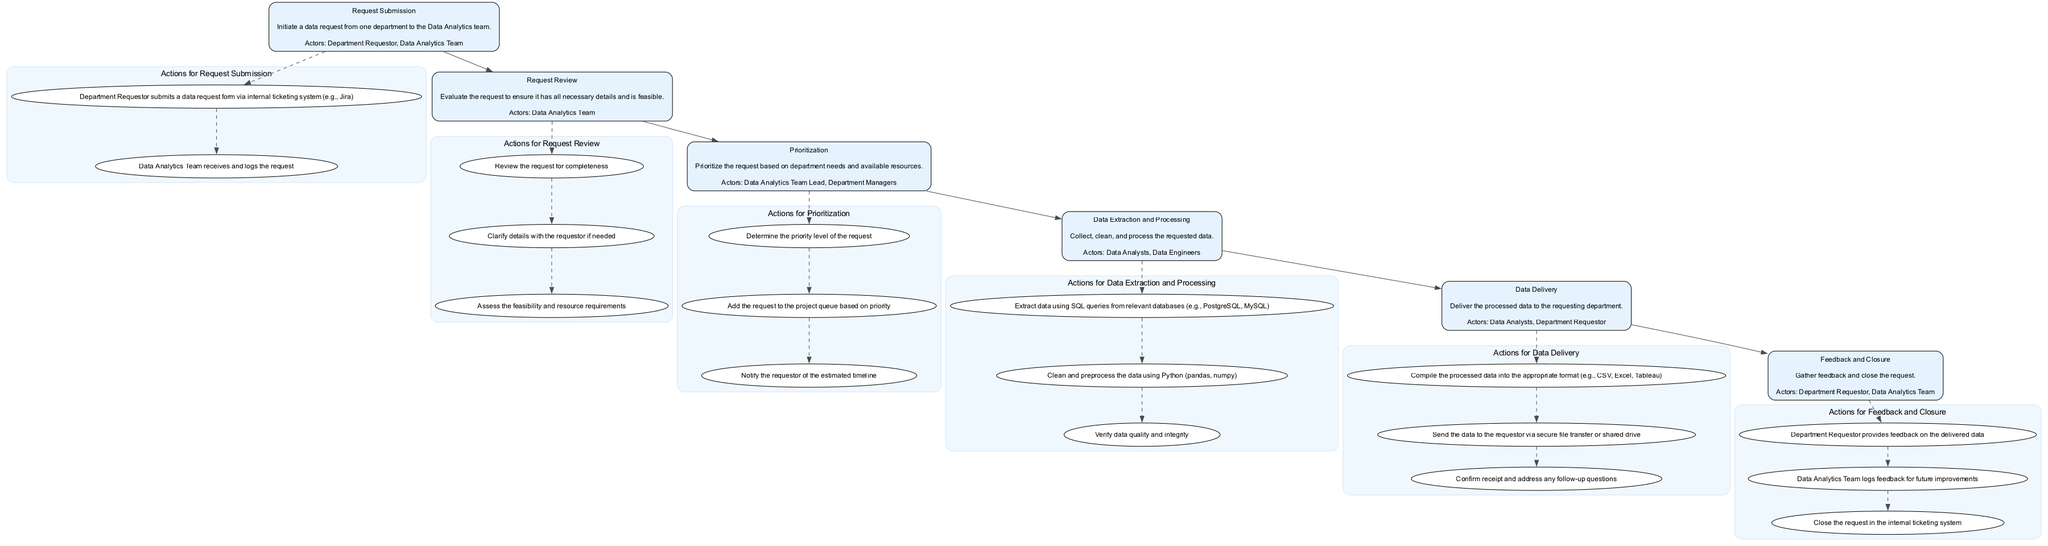What is the first stage in the process? The process begins with the "Request Submission" stage, which is the first node listed in the diagram.
Answer: Request Submission How many actors are involved in the "Data Extraction and Processing" stage? The "Data Extraction and Processing" stage has two actors listed: "Data Analysts" and "Data Engineers." By counting them, we find there are two actors.
Answer: Two What is the main action in the "Data Delivery" stage? The primary action listed under the "Data Delivery" stage is "Compile the processed data into the appropriate format (e.g., CSV, Excel, Tableau)." This is the first action shown in that stage.
Answer: Compile the processed data into the appropriate format Which stage follows "Prioritization"? The "Data Extraction and Processing" stage immediately follows the "Prioritization" stage, making it the next step in the flow after prioritizing the request.
Answer: Data Extraction and Processing What tools are used in the "Feedback and Closure" stage? The tools listed for the "Feedback and Closure" stage are "Jira," "Google Forms," and "Email." These are used by the actors during this stage.
Answer: Jira, Google Forms, and Email What actions are taken during the "Request Review" stage? The "Request Review" stage includes three actions: "Review the request for completeness," "Clarify details with the requestor if needed," and "Assess the feasibility and resource requirements." These actions are all part of this stage.
Answer: Review the request for completeness, Clarify details with the requestor if needed, Assess the feasibility and resource requirements Which actor is responsible for notifying the requestor of the estimated timeline? The "Data Analytics Team Lead" is responsible for notifying the requestor of the estimated timeline as part of the "Prioritization" stage activities.
Answer: Data Analytics Team Lead What is the last stage in the process? The last stage in the "Cross-Departmental Data Request and Fulfillment" process is the "Feedback and Closure" stage, which concludes the entire process.
Answer: Feedback and Closure How is data quality assessed during the process? Data quality is assessed during the "Data Extraction and Processing" stage, where the action "Verify data quality and integrity" takes place, ensuring that the data meets quality standards before delivery.
Answer: Verify data quality and integrity Which actors are involved in the "Request Submission" stage? The actors involved in the "Request Submission" stage are "Department Requestor" and "Data Analytics Team." This is reported directly under that stage's description.
Answer: Department Requestor and Data Analytics Team 